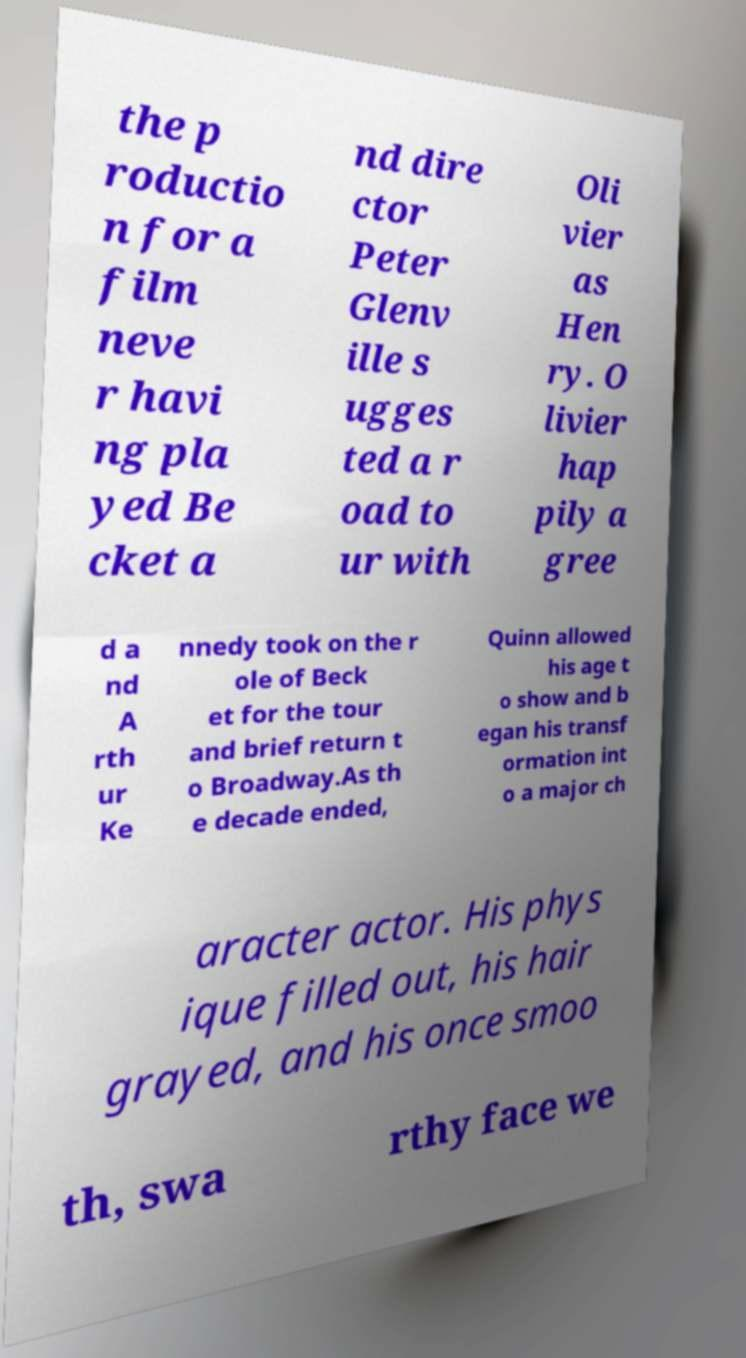Could you assist in decoding the text presented in this image and type it out clearly? the p roductio n for a film neve r havi ng pla yed Be cket a nd dire ctor Peter Glenv ille s ugges ted a r oad to ur with Oli vier as Hen ry. O livier hap pily a gree d a nd A rth ur Ke nnedy took on the r ole of Beck et for the tour and brief return t o Broadway.As th e decade ended, Quinn allowed his age t o show and b egan his transf ormation int o a major ch aracter actor. His phys ique filled out, his hair grayed, and his once smoo th, swa rthy face we 